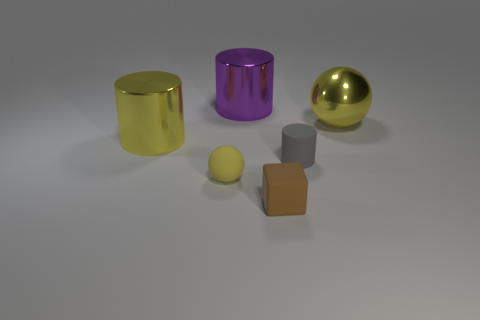Subtract all metallic cylinders. How many cylinders are left? 1 Add 1 small yellow matte spheres. How many objects exist? 7 Subtract all cubes. How many objects are left? 5 Subtract 0 blue balls. How many objects are left? 6 Subtract all big red shiny blocks. Subtract all yellow metallic spheres. How many objects are left? 5 Add 3 small matte things. How many small matte things are left? 6 Add 6 tiny rubber cubes. How many tiny rubber cubes exist? 7 